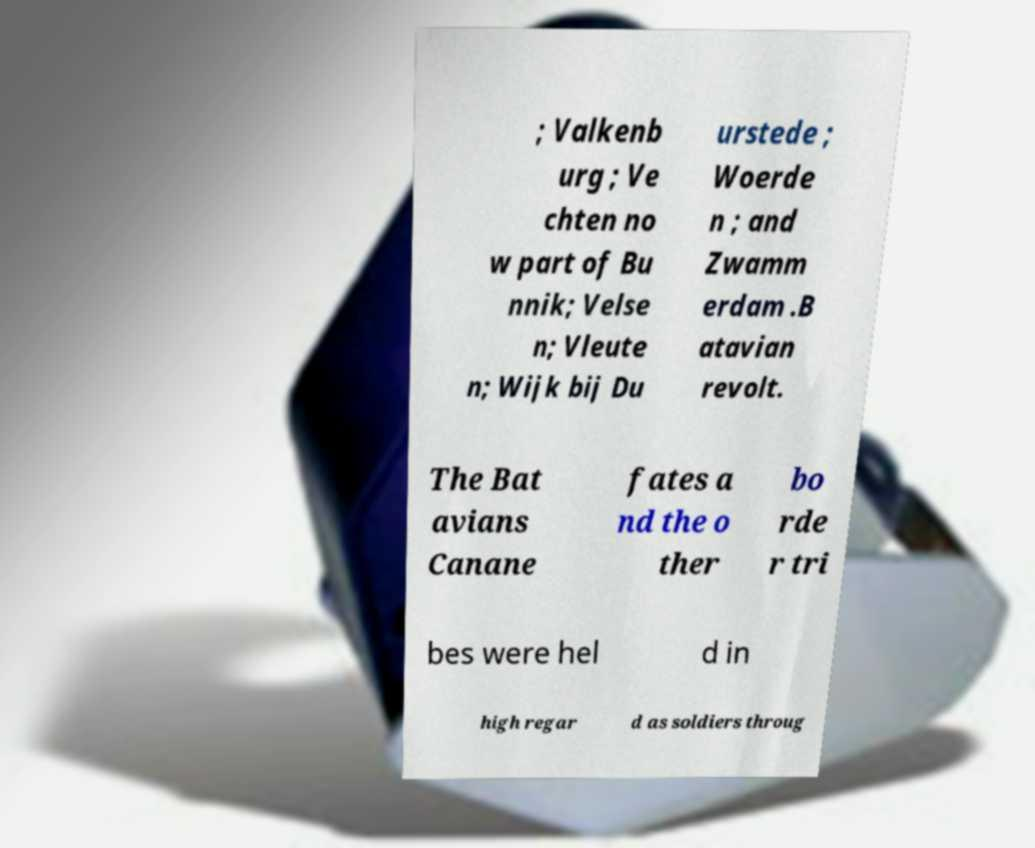For documentation purposes, I need the text within this image transcribed. Could you provide that? ; Valkenb urg ; Ve chten no w part of Bu nnik; Velse n; Vleute n; Wijk bij Du urstede ; Woerde n ; and Zwamm erdam .B atavian revolt. The Bat avians Canane fates a nd the o ther bo rde r tri bes were hel d in high regar d as soldiers throug 